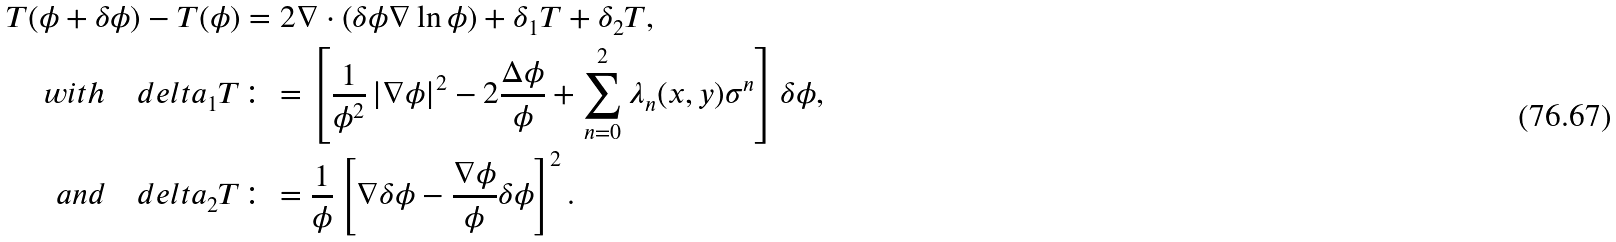<formula> <loc_0><loc_0><loc_500><loc_500>T ( \phi + \delta \phi ) - T ( \phi ) & = 2 \nabla \cdot \left ( \delta \phi \nabla \ln \phi \right ) + \delta _ { 1 } T + \delta _ { 2 } T , \\ w i t h \quad d e l t a _ { 1 } T & \colon = \left [ \frac { 1 } { \phi ^ { 2 } } \left | \nabla \phi \right | ^ { 2 } - 2 \frac { \Delta \phi } { \phi } + \sum _ { n = 0 } ^ { 2 } \lambda _ { n } ( x , y ) \sigma ^ { n } \right ] \delta \phi , \\ a n d \quad d e l t a _ { 2 } T & \colon = \frac { 1 } { \phi } \left [ \nabla \delta \phi - \frac { \nabla \phi } { \phi } \delta \phi \right ] ^ { 2 } .</formula> 